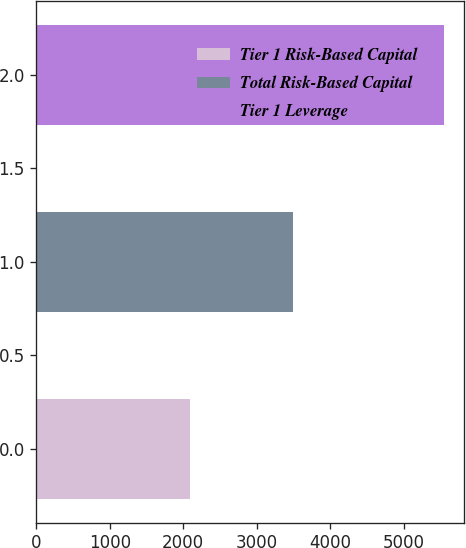Convert chart. <chart><loc_0><loc_0><loc_500><loc_500><bar_chart><fcel>Tier 1 Risk-Based Capital<fcel>Total Risk-Based Capital<fcel>Tier 1 Leverage<nl><fcel>2095<fcel>3492<fcel>5548<nl></chart> 